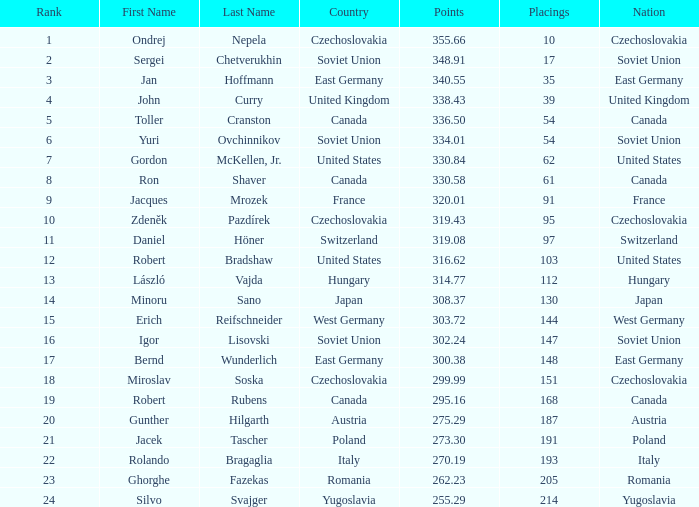In west germany, which positions have a nation with a score greater than 303.72 points? None. 